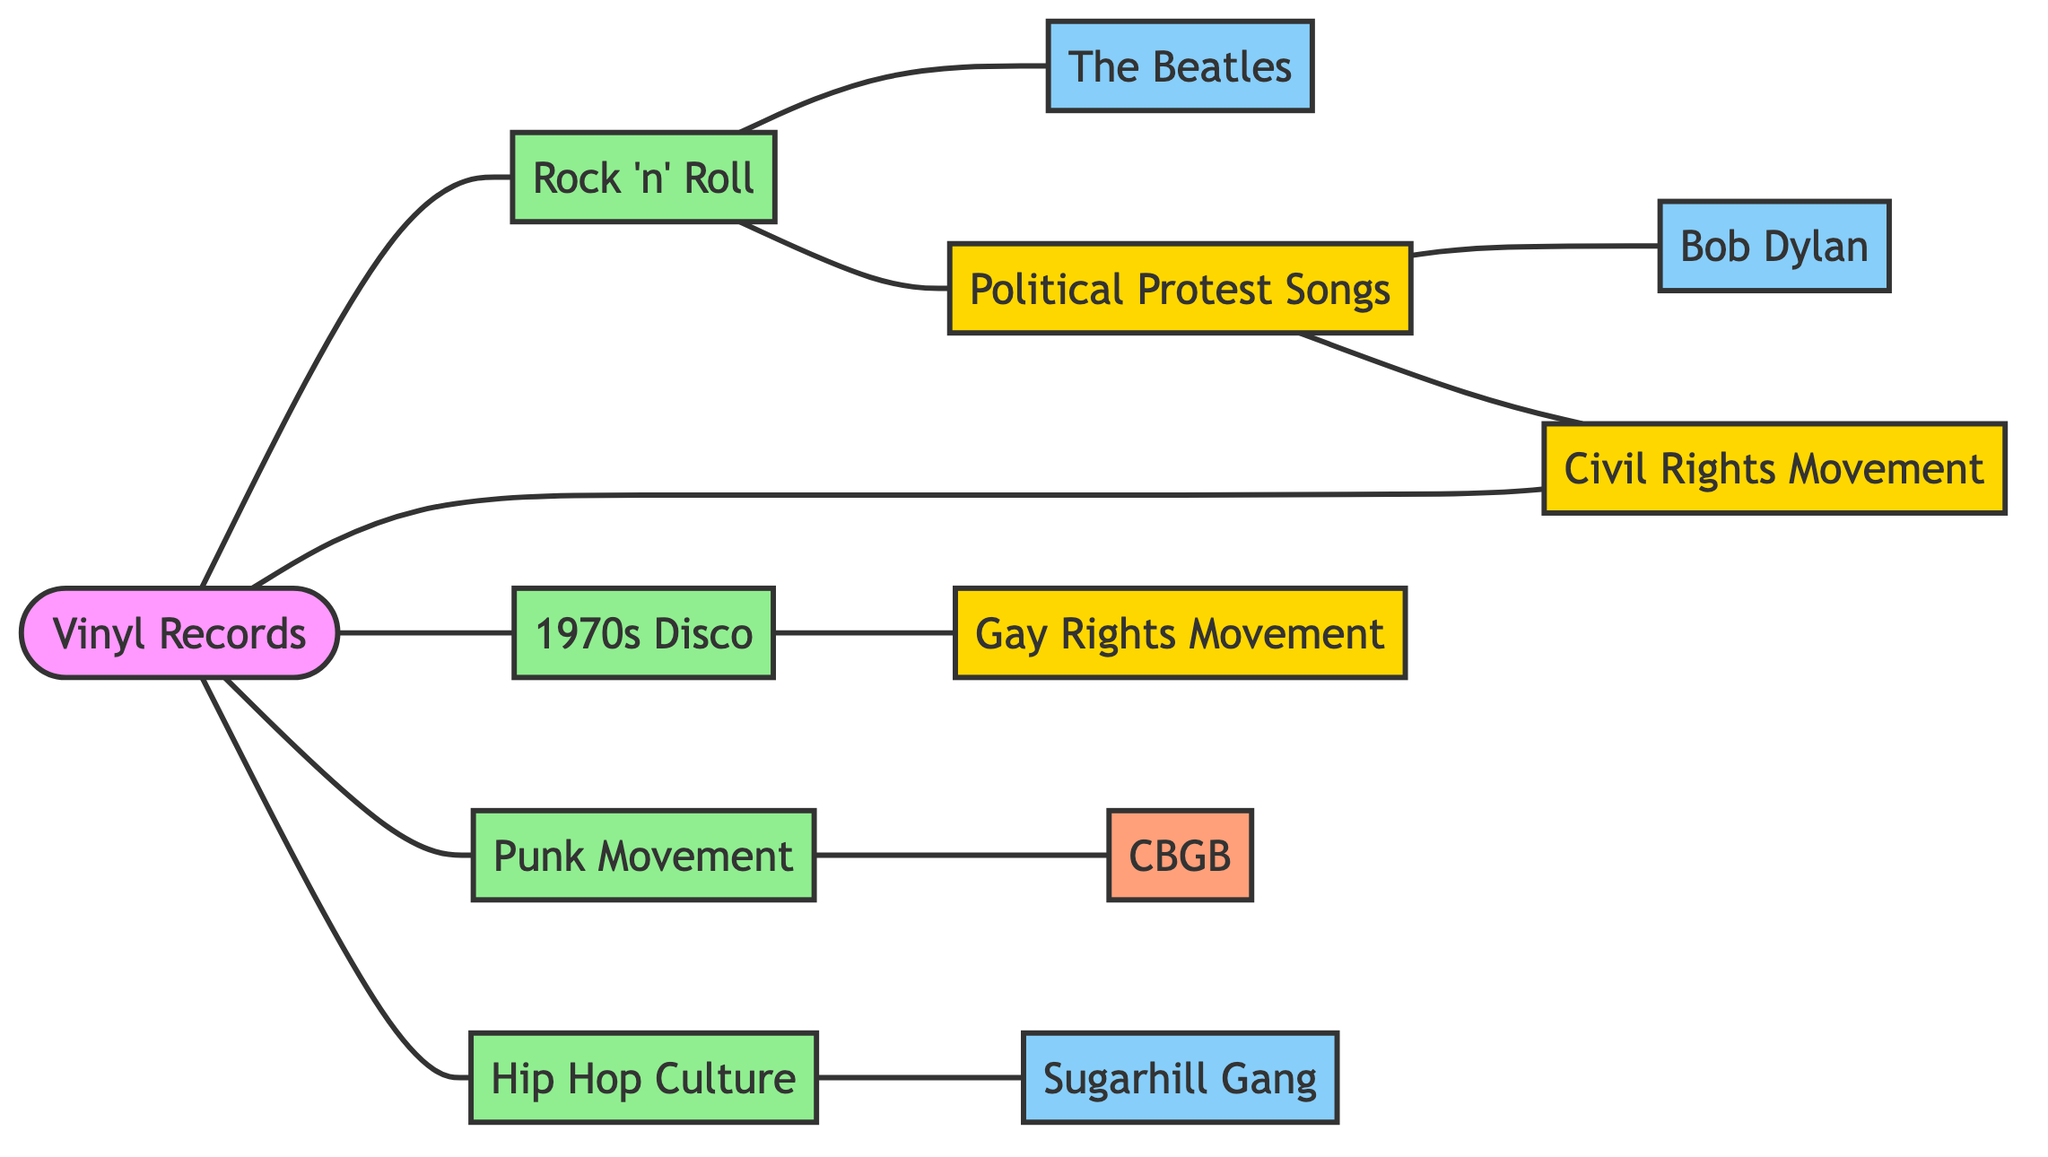What is the number of nodes in the diagram? The diagram contains nodes representing cultural movements, musical genres, artists, and a venue. Counting each unique node gives 12 nodes total.
Answer: 12 Which cultural movement is directly linked to the Civil Rights Movement? The edges connected to the Civil Rights Movement indicate its relationships. It is directly linked to Political Protest Songs and Vinyl Records.
Answer: Political Protest Songs How many artistic nodes are present in the diagram? The artistic nodes are The Beatles, Bob Dylan, and Sugarhill Gang. Counting these unique nodes reveals 3 artistic nodes.
Answer: 3 Which movement is connected to 1970s Disco? The diagram shows that the 1970s Disco node connects directly to the Gay Rights Movement.
Answer: Gay Rights Movement What is the relationship between Rock 'n' Roll and The Beatles? The diagram illustrates that Rock 'n' Roll is directly connected to The Beatles.
Answer: Directly connected Which nodes represent social movements? The social movements represented by the nodes are the Civil Rights Movement, Gay Rights Movement, and the Political Protest Songs.
Answer: Civil Rights Movement, Gay Rights Movement, Political Protest Songs How many edges connect the Punk Movement? The Punk Movement has two connections: one to CBGB and one to Vinyl Records, giving it a total of 2 edges.
Answer: 2 What is the link between Hip Hop Culture and Sugarhill Gang? The diagram shows a direct connection between Hip Hop Culture and Sugarhill Gang indicating that the latter is an integral part.
Answer: Direct connection Identify the node representing a venue in the diagram. Among the nodes, CBGB is specifically labeled as a venue, making it the sole representative.
Answer: CBGB Which musical movement is associated with Political Protest Songs? The diagram indicates that Political Protest Songs is linked to Rock 'n' Roll and Bob Dylan, showing its association with these elements.
Answer: Rock 'n' Roll and Bob Dylan 